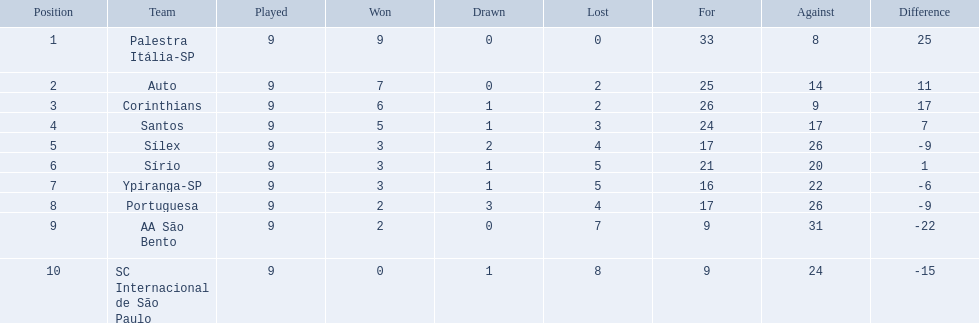What were all the teams that competed in 1926 brazilian football? Palestra Itália-SP, Auto, Corinthians, Santos, Sílex, Sírio, Ypiranga-SP, Portuguesa, AA São Bento, SC Internacional de São Paulo. Parse the full table in json format. {'header': ['Position', 'Team', 'Played', 'Won', 'Drawn', 'Lost', 'For', 'Against', 'Difference'], 'rows': [['1', 'Palestra Itália-SP', '9', '9', '0', '0', '33', '8', '25'], ['2', 'Auto', '9', '7', '0', '2', '25', '14', '11'], ['3', 'Corinthians', '9', '6', '1', '2', '26', '9', '17'], ['4', 'Santos', '9', '5', '1', '3', '24', '17', '7'], ['5', 'Sílex', '9', '3', '2', '4', '17', '26', '-9'], ['6', 'Sírio', '9', '3', '1', '5', '21', '20', '1'], ['7', 'Ypiranga-SP', '9', '3', '1', '5', '16', '22', '-6'], ['8', 'Portuguesa', '9', '2', '3', '4', '17', '26', '-9'], ['9', 'AA São Bento', '9', '2', '0', '7', '9', '31', '-22'], ['10', 'SC Internacional de São Paulo', '9', '0', '1', '8', '9', '24', '-15']]} Which of these had zero games lost? Palestra Itália-SP. What were the top three amounts of games won for 1926 in brazilian football season? 9, 7, 6. What were the top amount of games won for 1926 in brazilian football season? 9. What team won the top amount of games Palestra Itália-SP. 